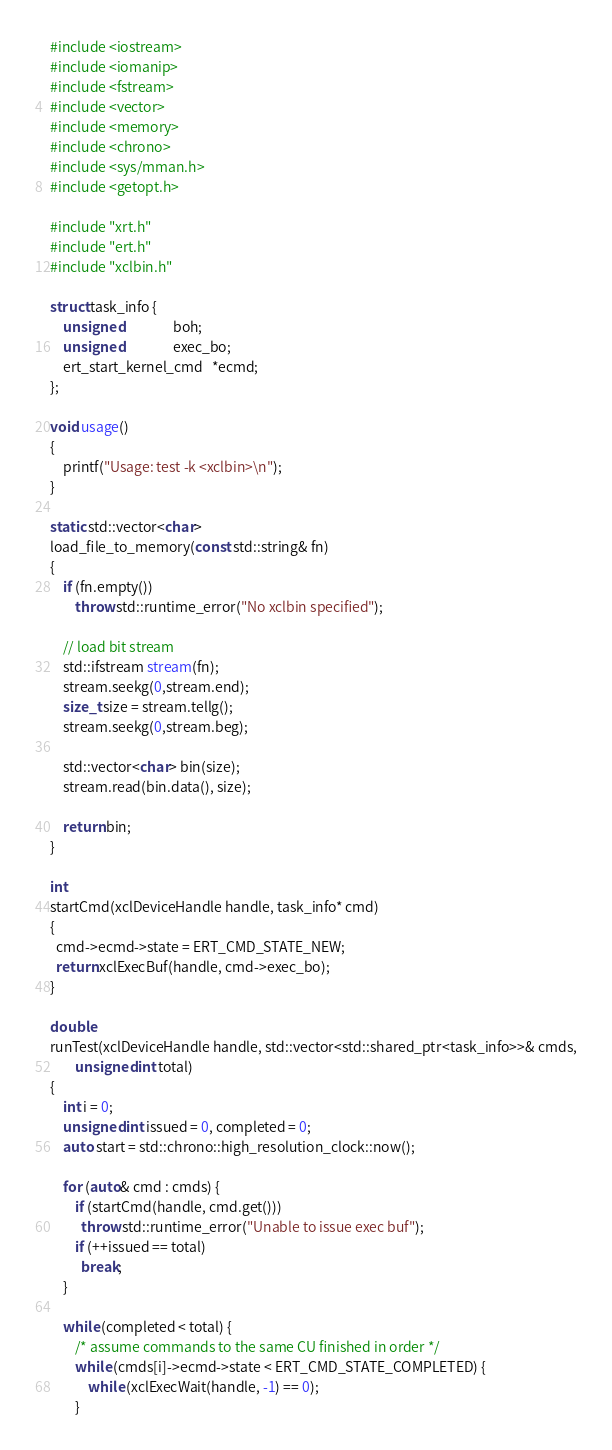Convert code to text. <code><loc_0><loc_0><loc_500><loc_500><_C++_>#include <iostream>
#include <iomanip>
#include <fstream>
#include <vector>
#include <memory>
#include <chrono>
#include <sys/mman.h>
#include <getopt.h>

#include "xrt.h"
#include "ert.h"
#include "xclbin.h"

struct task_info {
    unsigned                boh;
    unsigned                exec_bo;
    ert_start_kernel_cmd   *ecmd;
};

void usage()
{
    printf("Usage: test -k <xclbin>\n");
}

static std::vector<char>
load_file_to_memory(const std::string& fn)
{
    if (fn.empty())
        throw std::runtime_error("No xclbin specified");

    // load bit stream
    std::ifstream stream(fn);
    stream.seekg(0,stream.end);
    size_t size = stream.tellg();
    stream.seekg(0,stream.beg);

    std::vector<char> bin(size);
    stream.read(bin.data(), size);

    return bin;
}

int
startCmd(xclDeviceHandle handle, task_info* cmd)
{
  cmd->ecmd->state = ERT_CMD_STATE_NEW;
  return xclExecBuf(handle, cmd->exec_bo);
}

double
runTest(xclDeviceHandle handle, std::vector<std::shared_ptr<task_info>>& cmds,
        unsigned int total)
{
    int i = 0;
    unsigned int issued = 0, completed = 0;
    auto start = std::chrono::high_resolution_clock::now();

    for (auto& cmd : cmds) {
        if (startCmd(handle, cmd.get()))
          throw std::runtime_error("Unable to issue exec buf");
        if (++issued == total)
          break;
    }

    while (completed < total) {
        /* assume commands to the same CU finished in order */
        while (cmds[i]->ecmd->state < ERT_CMD_STATE_COMPLETED) {
            while (xclExecWait(handle, -1) == 0);
        }</code> 